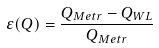<formula> <loc_0><loc_0><loc_500><loc_500>\varepsilon ( Q ) = \frac { Q _ { M e t r } - Q _ { W L } } { Q _ { M e t r } }</formula> 